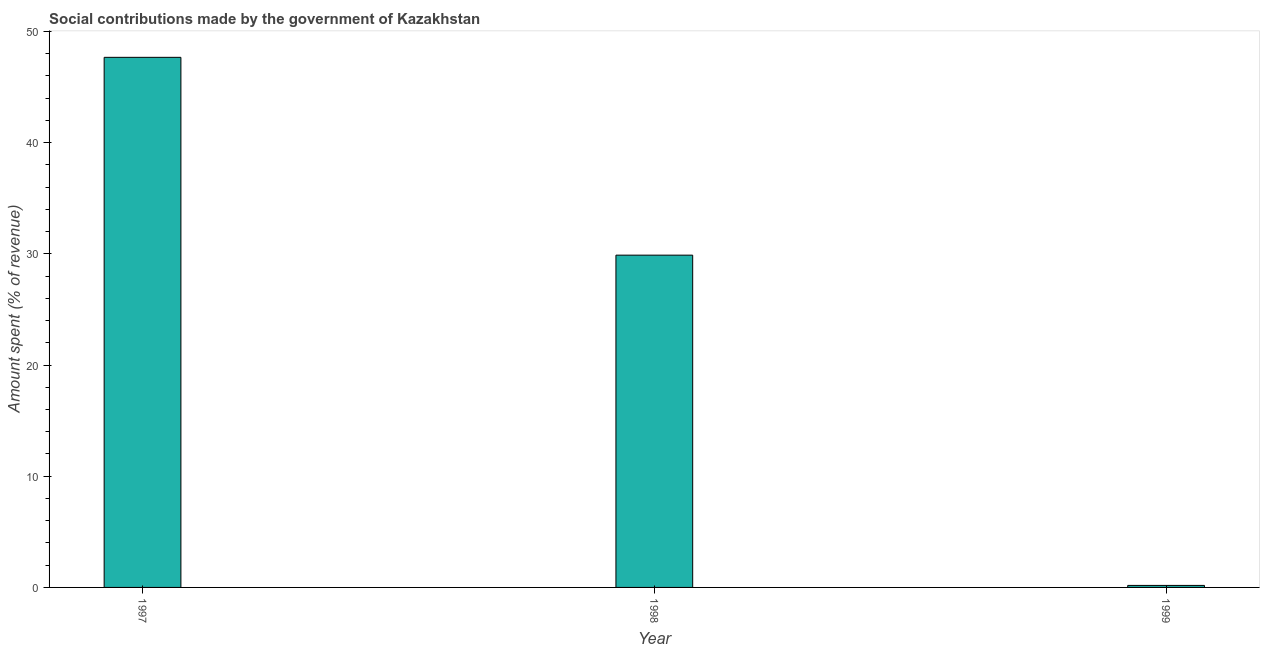Does the graph contain grids?
Your answer should be very brief. No. What is the title of the graph?
Make the answer very short. Social contributions made by the government of Kazakhstan. What is the label or title of the Y-axis?
Make the answer very short. Amount spent (% of revenue). What is the amount spent in making social contributions in 1999?
Your answer should be compact. 0.18. Across all years, what is the maximum amount spent in making social contributions?
Provide a short and direct response. 47.67. Across all years, what is the minimum amount spent in making social contributions?
Your answer should be very brief. 0.18. In which year was the amount spent in making social contributions maximum?
Offer a terse response. 1997. What is the sum of the amount spent in making social contributions?
Your answer should be very brief. 77.74. What is the difference between the amount spent in making social contributions in 1998 and 1999?
Your answer should be very brief. 29.7. What is the average amount spent in making social contributions per year?
Offer a very short reply. 25.91. What is the median amount spent in making social contributions?
Offer a terse response. 29.88. Do a majority of the years between 1999 and 1998 (inclusive) have amount spent in making social contributions greater than 40 %?
Ensure brevity in your answer.  No. What is the ratio of the amount spent in making social contributions in 1997 to that in 1998?
Ensure brevity in your answer.  1.59. Is the amount spent in making social contributions in 1997 less than that in 1998?
Ensure brevity in your answer.  No. Is the difference between the amount spent in making social contributions in 1997 and 1998 greater than the difference between any two years?
Your answer should be very brief. No. What is the difference between the highest and the second highest amount spent in making social contributions?
Your answer should be compact. 17.79. What is the difference between the highest and the lowest amount spent in making social contributions?
Offer a very short reply. 47.49. In how many years, is the amount spent in making social contributions greater than the average amount spent in making social contributions taken over all years?
Keep it short and to the point. 2. How many bars are there?
Keep it short and to the point. 3. How many years are there in the graph?
Offer a terse response. 3. What is the difference between two consecutive major ticks on the Y-axis?
Give a very brief answer. 10. Are the values on the major ticks of Y-axis written in scientific E-notation?
Your response must be concise. No. What is the Amount spent (% of revenue) in 1997?
Provide a succinct answer. 47.67. What is the Amount spent (% of revenue) of 1998?
Your answer should be very brief. 29.88. What is the Amount spent (% of revenue) of 1999?
Provide a succinct answer. 0.18. What is the difference between the Amount spent (% of revenue) in 1997 and 1998?
Offer a terse response. 17.79. What is the difference between the Amount spent (% of revenue) in 1997 and 1999?
Your response must be concise. 47.49. What is the difference between the Amount spent (% of revenue) in 1998 and 1999?
Keep it short and to the point. 29.7. What is the ratio of the Amount spent (% of revenue) in 1997 to that in 1998?
Provide a succinct answer. 1.59. What is the ratio of the Amount spent (% of revenue) in 1997 to that in 1999?
Offer a terse response. 263.04. What is the ratio of the Amount spent (% of revenue) in 1998 to that in 1999?
Offer a terse response. 164.88. 